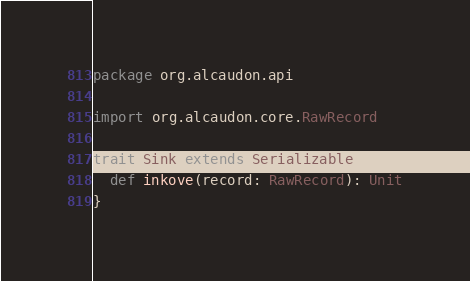<code> <loc_0><loc_0><loc_500><loc_500><_Scala_>package org.alcaudon.api

import org.alcaudon.core.RawRecord

trait Sink extends Serializable {
  def inkove(record: RawRecord): Unit
}
</code> 